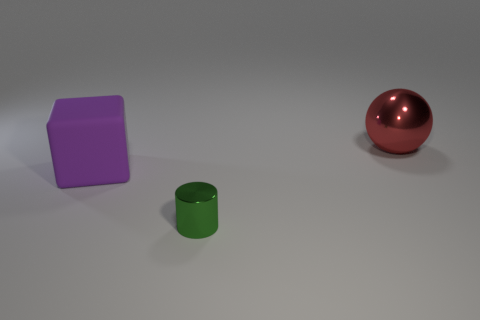Is the material of the large thing behind the large purple thing the same as the large purple block?
Keep it short and to the point. No. There is a thing that is both behind the shiny cylinder and to the right of the purple block; what is its color?
Give a very brief answer. Red. There is a object behind the purple thing; what number of small things are right of it?
Your answer should be compact. 0. What is the color of the cylinder?
Make the answer very short. Green. How many things are green objects or big matte objects?
Your answer should be very brief. 2. The big thing that is in front of the big thing that is right of the big purple matte block is what shape?
Offer a very short reply. Cube. How many other objects are the same material as the large sphere?
Provide a short and direct response. 1. Does the tiny cylinder have the same material as the big thing that is on the right side of the metallic cylinder?
Provide a succinct answer. Yes. What number of objects are either things behind the large rubber block or metal objects that are behind the purple rubber object?
Offer a very short reply. 1. What number of other objects are the same color as the block?
Give a very brief answer. 0. 